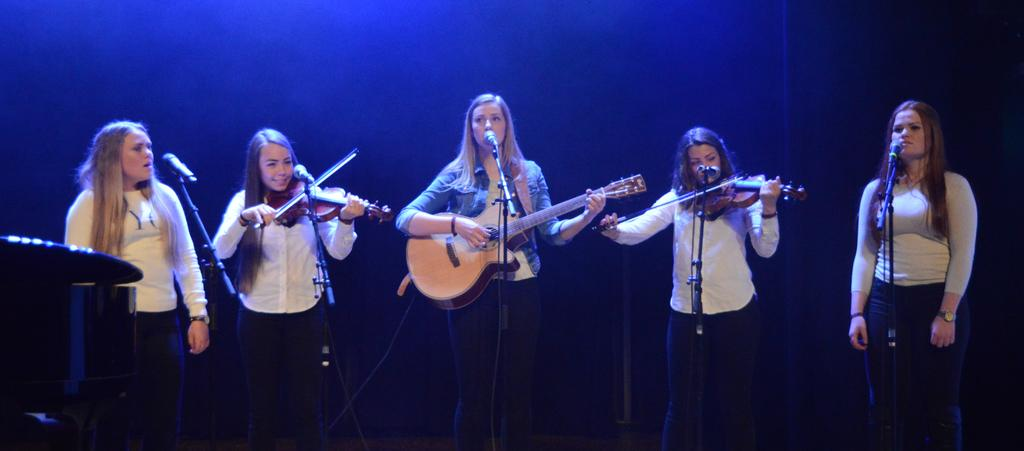What is the main subject of the image? The main subject of the image is women. What are the women doing in the image? Three of the women are playing musical instruments. Are there any animals present in the image? Yes, there are mice in front of the women. What type of nail is being used by the women to play their instruments? There is no mention of nails being used to play the instruments in the image. The women are likely using their hands or other parts of their bodies to play the instruments. 